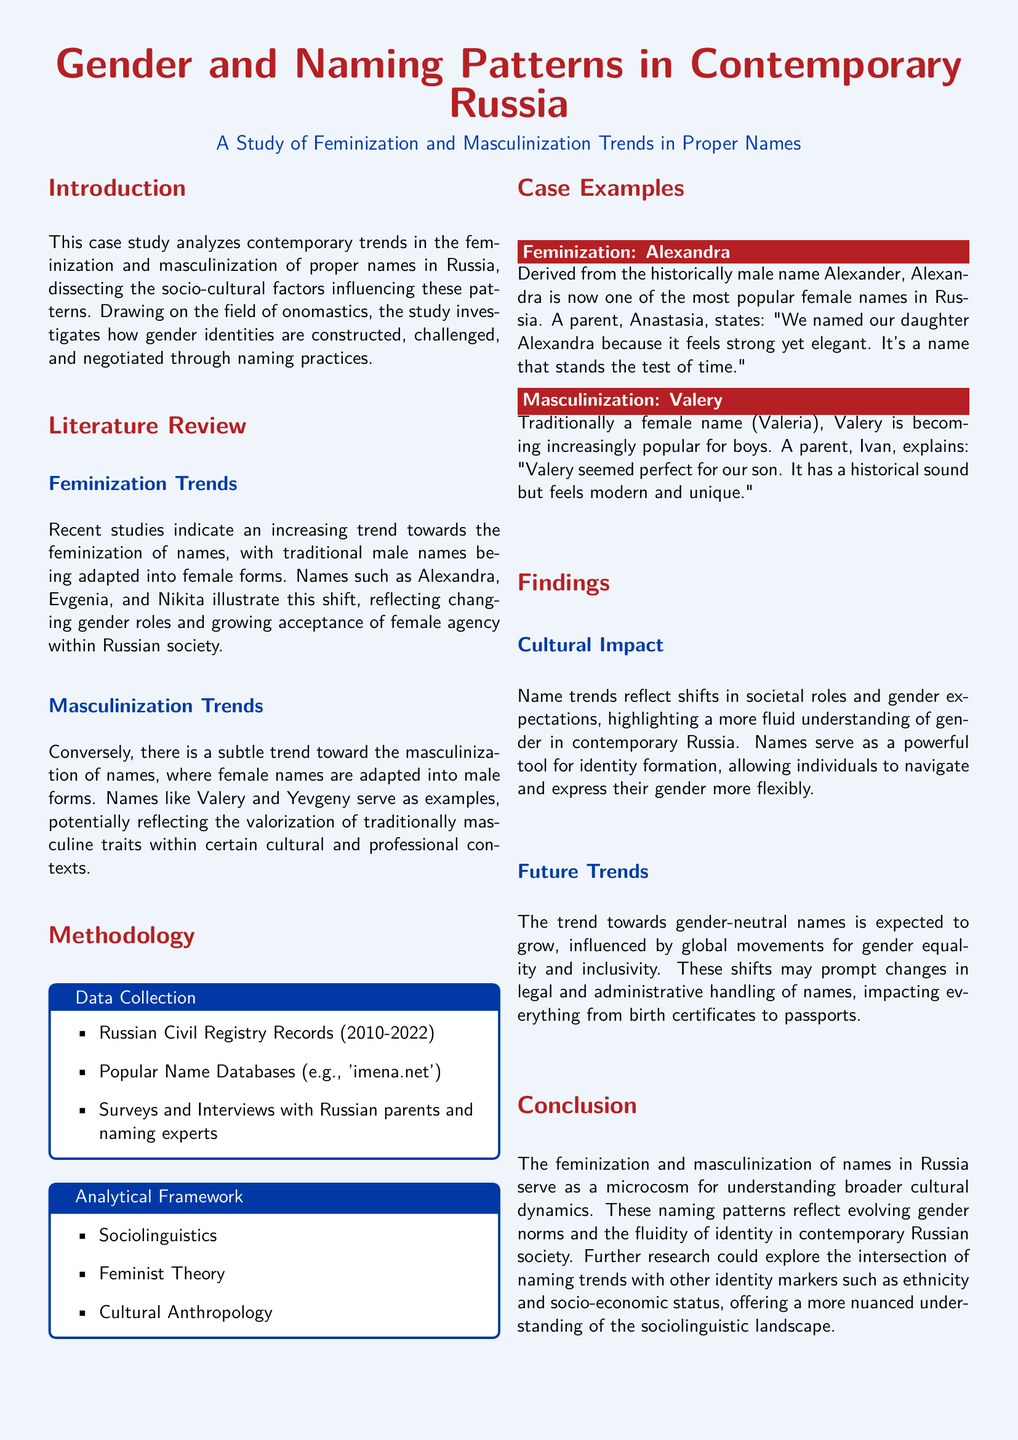What is the main topic of this case study? The case study focuses on contemporary trends in the feminization and masculinization of proper names in Russia.
Answer: Gender and Naming Patterns Which names exemplify feminization trends? The document mentions names that illustrate feminization trends, specifically highlighting altered male forms.
Answer: Alexandra, Evgenia, Nikita What are the sources of data collection? Data was collected from specific records and databases as stated in the methodology section.
Answer: Russian Civil Registry Records, Popular Name Databases, Surveys and Interviews What is the purpose of the case examples section? The section illustrates specific instances of both feminization and masculinization in naming trends to provide practical insights.
Answer: To provide specific instances of naming trends Which gender-related theory is part of the analytical framework? The document lists several theories in the analytical framework, one of which is specifically related to gender.
Answer: Feminist Theory What does the case study suggest about future naming trends? The document highlights an expected shift influenced by societal movements, indicating a direction toward more inclusive practices.
Answer: Gender-neutral names Name a traditional name mentioned that is becoming masculinized. The document provides examples of names that are undergoing this trend, specifically from female to male.
Answer: Valery What does the conclusion relate naming trends to? The conclusion makes a broader cultural connection based on the name trends discussed throughout the study.
Answer: Evolving gender norms 